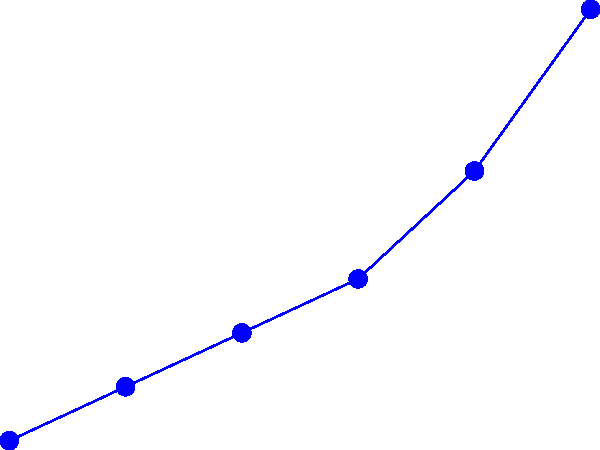Based on the line graph showing the frequency of different types of cyberattacks from 2015 to 2020, which type of attack experienced the most significant increase in frequency, and what could be a potential reason for this trend? To answer this question, we need to analyze the trends for each type of cyberattack:

1. DDoS (Distributed Denial of Service) attacks:
   - 2015: 20 per 1000 systems
   - 2020: 60 per 1000 systems
   - Increase: 40 per 1000 systems

2. Malware attacks:
   - 2015: 30 per 1000 systems
   - 2020: 55 per 1000 systems
   - Increase: 25 per 1000 systems

3. Phishing attacks:
   - 2015: 25 per 1000 systems
   - 2020: 65 per 1000 systems
   - Increase: 40 per 1000 systems

Phishing attacks show the most significant increase, rising by 40 per 1000 systems, similar to DDoS attacks. However, phishing attacks start lower and end higher, indicating a steeper overall growth curve.

A potential reason for this trend could be:
The increasing sophistication of phishing techniques, combined with the growing number of people working and studying remotely due to the COVID-19 pandemic. This situation has created more opportunities for cybercriminals to exploit human vulnerabilities through social engineering tactics, as people rely more heavily on digital communication and may be less vigilant when separated from their usual work environments.
Answer: Phishing attacks; increased remote work and sophisticated social engineering tactics. 